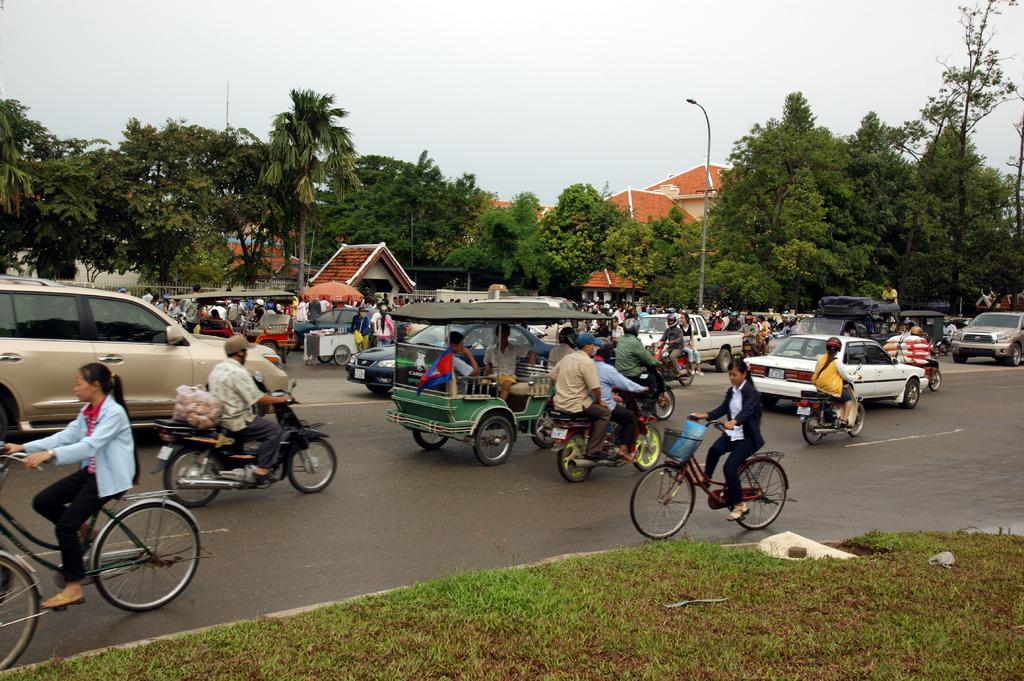Where was the image taken? The image was taken on a road. What types of vehicles can be seen in the image? There are motor vehicles and bicycles in the image. What other objects or structures are visible in the image? There are cars, trees, and buildings in the background of the image. How does the wrist of the person riding the motorcycle in the image affect their digestion? There is no information about the person's wrist or their digestion in the image, so we cannot determine any connection between the two. 